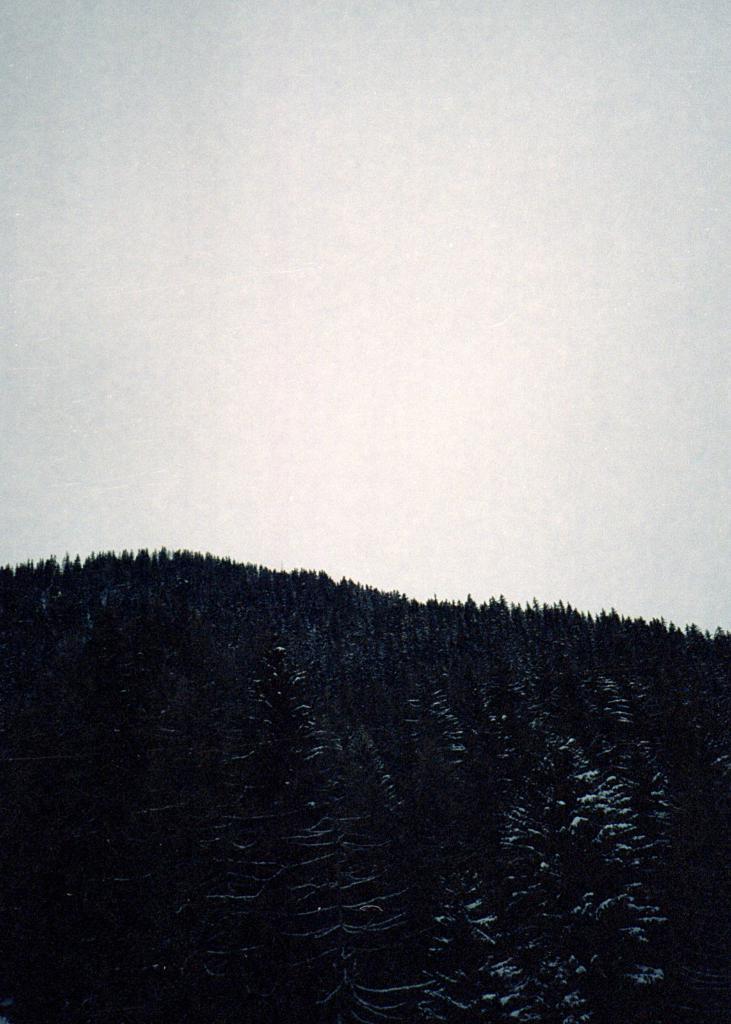Please provide a concise description of this image. In this picture there is a mountain and there are trees on the mountain and the sky is clear. 